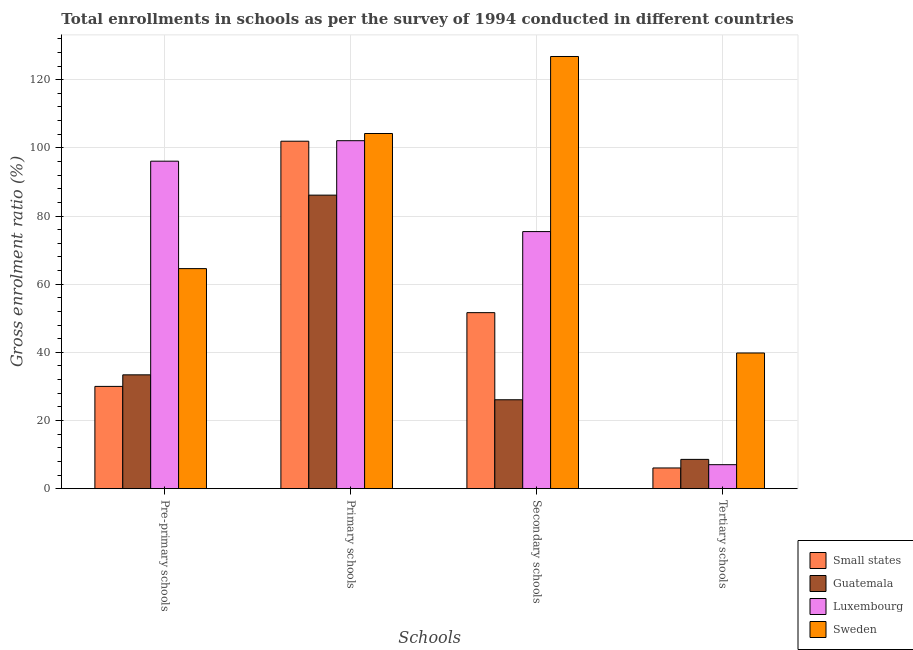How many groups of bars are there?
Provide a succinct answer. 4. Are the number of bars per tick equal to the number of legend labels?
Your answer should be compact. Yes. Are the number of bars on each tick of the X-axis equal?
Offer a very short reply. Yes. What is the label of the 3rd group of bars from the left?
Keep it short and to the point. Secondary schools. What is the gross enrolment ratio in secondary schools in Small states?
Provide a short and direct response. 51.65. Across all countries, what is the maximum gross enrolment ratio in secondary schools?
Your response must be concise. 126.8. Across all countries, what is the minimum gross enrolment ratio in tertiary schools?
Your response must be concise. 6.08. In which country was the gross enrolment ratio in primary schools minimum?
Your response must be concise. Guatemala. What is the total gross enrolment ratio in tertiary schools in the graph?
Your response must be concise. 61.52. What is the difference between the gross enrolment ratio in tertiary schools in Sweden and that in Guatemala?
Keep it short and to the point. 31.21. What is the difference between the gross enrolment ratio in secondary schools in Luxembourg and the gross enrolment ratio in primary schools in Guatemala?
Ensure brevity in your answer.  -10.7. What is the average gross enrolment ratio in primary schools per country?
Your response must be concise. 98.59. What is the difference between the gross enrolment ratio in tertiary schools and gross enrolment ratio in pre-primary schools in Luxembourg?
Ensure brevity in your answer.  -89.05. What is the ratio of the gross enrolment ratio in tertiary schools in Luxembourg to that in Sweden?
Offer a terse response. 0.18. Is the gross enrolment ratio in pre-primary schools in Guatemala less than that in Luxembourg?
Your answer should be very brief. Yes. Is the difference between the gross enrolment ratio in secondary schools in Guatemala and Small states greater than the difference between the gross enrolment ratio in primary schools in Guatemala and Small states?
Offer a very short reply. No. What is the difference between the highest and the second highest gross enrolment ratio in secondary schools?
Your response must be concise. 51.37. What is the difference between the highest and the lowest gross enrolment ratio in primary schools?
Offer a very short reply. 18.08. Is it the case that in every country, the sum of the gross enrolment ratio in tertiary schools and gross enrolment ratio in primary schools is greater than the sum of gross enrolment ratio in secondary schools and gross enrolment ratio in pre-primary schools?
Make the answer very short. No. What does the 3rd bar from the left in Pre-primary schools represents?
Your answer should be compact. Luxembourg. What does the 2nd bar from the right in Secondary schools represents?
Offer a very short reply. Luxembourg. Is it the case that in every country, the sum of the gross enrolment ratio in pre-primary schools and gross enrolment ratio in primary schools is greater than the gross enrolment ratio in secondary schools?
Your answer should be compact. Yes. How many bars are there?
Offer a terse response. 16. Are all the bars in the graph horizontal?
Make the answer very short. No. How many countries are there in the graph?
Make the answer very short. 4. Does the graph contain grids?
Offer a very short reply. Yes. Where does the legend appear in the graph?
Your response must be concise. Bottom right. How are the legend labels stacked?
Make the answer very short. Vertical. What is the title of the graph?
Offer a terse response. Total enrollments in schools as per the survey of 1994 conducted in different countries. What is the label or title of the X-axis?
Ensure brevity in your answer.  Schools. What is the Gross enrolment ratio (%) of Small states in Pre-primary schools?
Provide a short and direct response. 30.01. What is the Gross enrolment ratio (%) of Guatemala in Pre-primary schools?
Offer a very short reply. 33.4. What is the Gross enrolment ratio (%) of Luxembourg in Pre-primary schools?
Your answer should be compact. 96.09. What is the Gross enrolment ratio (%) of Sweden in Pre-primary schools?
Keep it short and to the point. 64.56. What is the Gross enrolment ratio (%) of Small states in Primary schools?
Your answer should be very brief. 101.95. What is the Gross enrolment ratio (%) in Guatemala in Primary schools?
Offer a very short reply. 86.13. What is the Gross enrolment ratio (%) in Luxembourg in Primary schools?
Ensure brevity in your answer.  102.1. What is the Gross enrolment ratio (%) of Sweden in Primary schools?
Your response must be concise. 104.2. What is the Gross enrolment ratio (%) in Small states in Secondary schools?
Make the answer very short. 51.65. What is the Gross enrolment ratio (%) in Guatemala in Secondary schools?
Keep it short and to the point. 26.09. What is the Gross enrolment ratio (%) in Luxembourg in Secondary schools?
Your answer should be very brief. 75.43. What is the Gross enrolment ratio (%) of Sweden in Secondary schools?
Make the answer very short. 126.8. What is the Gross enrolment ratio (%) of Small states in Tertiary schools?
Keep it short and to the point. 6.08. What is the Gross enrolment ratio (%) of Guatemala in Tertiary schools?
Ensure brevity in your answer.  8.59. What is the Gross enrolment ratio (%) in Luxembourg in Tertiary schools?
Your response must be concise. 7.04. What is the Gross enrolment ratio (%) of Sweden in Tertiary schools?
Offer a terse response. 39.81. Across all Schools, what is the maximum Gross enrolment ratio (%) in Small states?
Make the answer very short. 101.95. Across all Schools, what is the maximum Gross enrolment ratio (%) in Guatemala?
Provide a succinct answer. 86.13. Across all Schools, what is the maximum Gross enrolment ratio (%) of Luxembourg?
Provide a succinct answer. 102.1. Across all Schools, what is the maximum Gross enrolment ratio (%) in Sweden?
Offer a very short reply. 126.8. Across all Schools, what is the minimum Gross enrolment ratio (%) in Small states?
Keep it short and to the point. 6.08. Across all Schools, what is the minimum Gross enrolment ratio (%) of Guatemala?
Ensure brevity in your answer.  8.59. Across all Schools, what is the minimum Gross enrolment ratio (%) in Luxembourg?
Your answer should be very brief. 7.04. Across all Schools, what is the minimum Gross enrolment ratio (%) in Sweden?
Your answer should be very brief. 39.81. What is the total Gross enrolment ratio (%) of Small states in the graph?
Make the answer very short. 189.67. What is the total Gross enrolment ratio (%) of Guatemala in the graph?
Keep it short and to the point. 154.21. What is the total Gross enrolment ratio (%) of Luxembourg in the graph?
Your response must be concise. 280.65. What is the total Gross enrolment ratio (%) in Sweden in the graph?
Your response must be concise. 335.38. What is the difference between the Gross enrolment ratio (%) of Small states in Pre-primary schools and that in Primary schools?
Offer a terse response. -71.94. What is the difference between the Gross enrolment ratio (%) in Guatemala in Pre-primary schools and that in Primary schools?
Provide a short and direct response. -52.72. What is the difference between the Gross enrolment ratio (%) in Luxembourg in Pre-primary schools and that in Primary schools?
Give a very brief answer. -6.01. What is the difference between the Gross enrolment ratio (%) of Sweden in Pre-primary schools and that in Primary schools?
Provide a short and direct response. -39.64. What is the difference between the Gross enrolment ratio (%) of Small states in Pre-primary schools and that in Secondary schools?
Your answer should be very brief. -21.64. What is the difference between the Gross enrolment ratio (%) in Guatemala in Pre-primary schools and that in Secondary schools?
Keep it short and to the point. 7.31. What is the difference between the Gross enrolment ratio (%) in Luxembourg in Pre-primary schools and that in Secondary schools?
Your answer should be very brief. 20.66. What is the difference between the Gross enrolment ratio (%) in Sweden in Pre-primary schools and that in Secondary schools?
Your answer should be very brief. -62.24. What is the difference between the Gross enrolment ratio (%) of Small states in Pre-primary schools and that in Tertiary schools?
Ensure brevity in your answer.  23.93. What is the difference between the Gross enrolment ratio (%) of Guatemala in Pre-primary schools and that in Tertiary schools?
Offer a terse response. 24.81. What is the difference between the Gross enrolment ratio (%) in Luxembourg in Pre-primary schools and that in Tertiary schools?
Ensure brevity in your answer.  89.05. What is the difference between the Gross enrolment ratio (%) in Sweden in Pre-primary schools and that in Tertiary schools?
Give a very brief answer. 24.75. What is the difference between the Gross enrolment ratio (%) in Small states in Primary schools and that in Secondary schools?
Provide a short and direct response. 50.3. What is the difference between the Gross enrolment ratio (%) of Guatemala in Primary schools and that in Secondary schools?
Your response must be concise. 60.04. What is the difference between the Gross enrolment ratio (%) of Luxembourg in Primary schools and that in Secondary schools?
Provide a succinct answer. 26.67. What is the difference between the Gross enrolment ratio (%) of Sweden in Primary schools and that in Secondary schools?
Your answer should be very brief. -22.6. What is the difference between the Gross enrolment ratio (%) of Small states in Primary schools and that in Tertiary schools?
Provide a short and direct response. 95.87. What is the difference between the Gross enrolment ratio (%) of Guatemala in Primary schools and that in Tertiary schools?
Keep it short and to the point. 77.53. What is the difference between the Gross enrolment ratio (%) in Luxembourg in Primary schools and that in Tertiary schools?
Ensure brevity in your answer.  95.06. What is the difference between the Gross enrolment ratio (%) of Sweden in Primary schools and that in Tertiary schools?
Provide a succinct answer. 64.4. What is the difference between the Gross enrolment ratio (%) in Small states in Secondary schools and that in Tertiary schools?
Your answer should be very brief. 45.57. What is the difference between the Gross enrolment ratio (%) in Guatemala in Secondary schools and that in Tertiary schools?
Provide a succinct answer. 17.49. What is the difference between the Gross enrolment ratio (%) of Luxembourg in Secondary schools and that in Tertiary schools?
Offer a terse response. 68.39. What is the difference between the Gross enrolment ratio (%) of Sweden in Secondary schools and that in Tertiary schools?
Give a very brief answer. 87. What is the difference between the Gross enrolment ratio (%) of Small states in Pre-primary schools and the Gross enrolment ratio (%) of Guatemala in Primary schools?
Give a very brief answer. -56.12. What is the difference between the Gross enrolment ratio (%) of Small states in Pre-primary schools and the Gross enrolment ratio (%) of Luxembourg in Primary schools?
Your answer should be very brief. -72.09. What is the difference between the Gross enrolment ratio (%) in Small states in Pre-primary schools and the Gross enrolment ratio (%) in Sweden in Primary schools?
Offer a terse response. -74.2. What is the difference between the Gross enrolment ratio (%) of Guatemala in Pre-primary schools and the Gross enrolment ratio (%) of Luxembourg in Primary schools?
Your answer should be compact. -68.69. What is the difference between the Gross enrolment ratio (%) in Guatemala in Pre-primary schools and the Gross enrolment ratio (%) in Sweden in Primary schools?
Keep it short and to the point. -70.8. What is the difference between the Gross enrolment ratio (%) in Luxembourg in Pre-primary schools and the Gross enrolment ratio (%) in Sweden in Primary schools?
Provide a short and direct response. -8.12. What is the difference between the Gross enrolment ratio (%) in Small states in Pre-primary schools and the Gross enrolment ratio (%) in Guatemala in Secondary schools?
Provide a succinct answer. 3.92. What is the difference between the Gross enrolment ratio (%) of Small states in Pre-primary schools and the Gross enrolment ratio (%) of Luxembourg in Secondary schools?
Ensure brevity in your answer.  -45.42. What is the difference between the Gross enrolment ratio (%) of Small states in Pre-primary schools and the Gross enrolment ratio (%) of Sweden in Secondary schools?
Make the answer very short. -96.8. What is the difference between the Gross enrolment ratio (%) in Guatemala in Pre-primary schools and the Gross enrolment ratio (%) in Luxembourg in Secondary schools?
Offer a terse response. -42.03. What is the difference between the Gross enrolment ratio (%) in Guatemala in Pre-primary schools and the Gross enrolment ratio (%) in Sweden in Secondary schools?
Your answer should be very brief. -93.4. What is the difference between the Gross enrolment ratio (%) of Luxembourg in Pre-primary schools and the Gross enrolment ratio (%) of Sweden in Secondary schools?
Your answer should be very brief. -30.71. What is the difference between the Gross enrolment ratio (%) in Small states in Pre-primary schools and the Gross enrolment ratio (%) in Guatemala in Tertiary schools?
Your answer should be compact. 21.41. What is the difference between the Gross enrolment ratio (%) of Small states in Pre-primary schools and the Gross enrolment ratio (%) of Luxembourg in Tertiary schools?
Keep it short and to the point. 22.97. What is the difference between the Gross enrolment ratio (%) in Small states in Pre-primary schools and the Gross enrolment ratio (%) in Sweden in Tertiary schools?
Keep it short and to the point. -9.8. What is the difference between the Gross enrolment ratio (%) of Guatemala in Pre-primary schools and the Gross enrolment ratio (%) of Luxembourg in Tertiary schools?
Keep it short and to the point. 26.36. What is the difference between the Gross enrolment ratio (%) in Guatemala in Pre-primary schools and the Gross enrolment ratio (%) in Sweden in Tertiary schools?
Provide a succinct answer. -6.41. What is the difference between the Gross enrolment ratio (%) of Luxembourg in Pre-primary schools and the Gross enrolment ratio (%) of Sweden in Tertiary schools?
Your response must be concise. 56.28. What is the difference between the Gross enrolment ratio (%) in Small states in Primary schools and the Gross enrolment ratio (%) in Guatemala in Secondary schools?
Your answer should be very brief. 75.86. What is the difference between the Gross enrolment ratio (%) in Small states in Primary schools and the Gross enrolment ratio (%) in Luxembourg in Secondary schools?
Your answer should be compact. 26.52. What is the difference between the Gross enrolment ratio (%) of Small states in Primary schools and the Gross enrolment ratio (%) of Sweden in Secondary schools?
Provide a succinct answer. -24.86. What is the difference between the Gross enrolment ratio (%) in Guatemala in Primary schools and the Gross enrolment ratio (%) in Luxembourg in Secondary schools?
Your response must be concise. 10.7. What is the difference between the Gross enrolment ratio (%) of Guatemala in Primary schools and the Gross enrolment ratio (%) of Sweden in Secondary schools?
Offer a terse response. -40.68. What is the difference between the Gross enrolment ratio (%) of Luxembourg in Primary schools and the Gross enrolment ratio (%) of Sweden in Secondary schools?
Keep it short and to the point. -24.71. What is the difference between the Gross enrolment ratio (%) in Small states in Primary schools and the Gross enrolment ratio (%) in Guatemala in Tertiary schools?
Keep it short and to the point. 93.35. What is the difference between the Gross enrolment ratio (%) in Small states in Primary schools and the Gross enrolment ratio (%) in Luxembourg in Tertiary schools?
Offer a very short reply. 94.91. What is the difference between the Gross enrolment ratio (%) of Small states in Primary schools and the Gross enrolment ratio (%) of Sweden in Tertiary schools?
Provide a short and direct response. 62.14. What is the difference between the Gross enrolment ratio (%) of Guatemala in Primary schools and the Gross enrolment ratio (%) of Luxembourg in Tertiary schools?
Provide a short and direct response. 79.09. What is the difference between the Gross enrolment ratio (%) of Guatemala in Primary schools and the Gross enrolment ratio (%) of Sweden in Tertiary schools?
Keep it short and to the point. 46.32. What is the difference between the Gross enrolment ratio (%) of Luxembourg in Primary schools and the Gross enrolment ratio (%) of Sweden in Tertiary schools?
Offer a terse response. 62.29. What is the difference between the Gross enrolment ratio (%) in Small states in Secondary schools and the Gross enrolment ratio (%) in Guatemala in Tertiary schools?
Provide a short and direct response. 43.05. What is the difference between the Gross enrolment ratio (%) of Small states in Secondary schools and the Gross enrolment ratio (%) of Luxembourg in Tertiary schools?
Make the answer very short. 44.61. What is the difference between the Gross enrolment ratio (%) in Small states in Secondary schools and the Gross enrolment ratio (%) in Sweden in Tertiary schools?
Ensure brevity in your answer.  11.84. What is the difference between the Gross enrolment ratio (%) in Guatemala in Secondary schools and the Gross enrolment ratio (%) in Luxembourg in Tertiary schools?
Give a very brief answer. 19.05. What is the difference between the Gross enrolment ratio (%) in Guatemala in Secondary schools and the Gross enrolment ratio (%) in Sweden in Tertiary schools?
Your answer should be very brief. -13.72. What is the difference between the Gross enrolment ratio (%) of Luxembourg in Secondary schools and the Gross enrolment ratio (%) of Sweden in Tertiary schools?
Ensure brevity in your answer.  35.62. What is the average Gross enrolment ratio (%) in Small states per Schools?
Your answer should be compact. 47.42. What is the average Gross enrolment ratio (%) in Guatemala per Schools?
Give a very brief answer. 38.55. What is the average Gross enrolment ratio (%) in Luxembourg per Schools?
Ensure brevity in your answer.  70.16. What is the average Gross enrolment ratio (%) in Sweden per Schools?
Give a very brief answer. 83.84. What is the difference between the Gross enrolment ratio (%) of Small states and Gross enrolment ratio (%) of Guatemala in Pre-primary schools?
Make the answer very short. -3.4. What is the difference between the Gross enrolment ratio (%) in Small states and Gross enrolment ratio (%) in Luxembourg in Pre-primary schools?
Offer a very short reply. -66.08. What is the difference between the Gross enrolment ratio (%) of Small states and Gross enrolment ratio (%) of Sweden in Pre-primary schools?
Your answer should be very brief. -34.56. What is the difference between the Gross enrolment ratio (%) in Guatemala and Gross enrolment ratio (%) in Luxembourg in Pre-primary schools?
Your answer should be very brief. -62.69. What is the difference between the Gross enrolment ratio (%) in Guatemala and Gross enrolment ratio (%) in Sweden in Pre-primary schools?
Your answer should be very brief. -31.16. What is the difference between the Gross enrolment ratio (%) in Luxembourg and Gross enrolment ratio (%) in Sweden in Pre-primary schools?
Keep it short and to the point. 31.53. What is the difference between the Gross enrolment ratio (%) of Small states and Gross enrolment ratio (%) of Guatemala in Primary schools?
Make the answer very short. 15.82. What is the difference between the Gross enrolment ratio (%) of Small states and Gross enrolment ratio (%) of Sweden in Primary schools?
Keep it short and to the point. -2.26. What is the difference between the Gross enrolment ratio (%) of Guatemala and Gross enrolment ratio (%) of Luxembourg in Primary schools?
Provide a succinct answer. -15.97. What is the difference between the Gross enrolment ratio (%) of Guatemala and Gross enrolment ratio (%) of Sweden in Primary schools?
Give a very brief answer. -18.08. What is the difference between the Gross enrolment ratio (%) of Luxembourg and Gross enrolment ratio (%) of Sweden in Primary schools?
Provide a succinct answer. -2.11. What is the difference between the Gross enrolment ratio (%) of Small states and Gross enrolment ratio (%) of Guatemala in Secondary schools?
Give a very brief answer. 25.56. What is the difference between the Gross enrolment ratio (%) of Small states and Gross enrolment ratio (%) of Luxembourg in Secondary schools?
Provide a succinct answer. -23.78. What is the difference between the Gross enrolment ratio (%) in Small states and Gross enrolment ratio (%) in Sweden in Secondary schools?
Provide a succinct answer. -75.16. What is the difference between the Gross enrolment ratio (%) in Guatemala and Gross enrolment ratio (%) in Luxembourg in Secondary schools?
Give a very brief answer. -49.34. What is the difference between the Gross enrolment ratio (%) in Guatemala and Gross enrolment ratio (%) in Sweden in Secondary schools?
Give a very brief answer. -100.71. What is the difference between the Gross enrolment ratio (%) in Luxembourg and Gross enrolment ratio (%) in Sweden in Secondary schools?
Ensure brevity in your answer.  -51.37. What is the difference between the Gross enrolment ratio (%) in Small states and Gross enrolment ratio (%) in Guatemala in Tertiary schools?
Provide a short and direct response. -2.52. What is the difference between the Gross enrolment ratio (%) in Small states and Gross enrolment ratio (%) in Luxembourg in Tertiary schools?
Your answer should be compact. -0.96. What is the difference between the Gross enrolment ratio (%) in Small states and Gross enrolment ratio (%) in Sweden in Tertiary schools?
Your answer should be very brief. -33.73. What is the difference between the Gross enrolment ratio (%) in Guatemala and Gross enrolment ratio (%) in Luxembourg in Tertiary schools?
Give a very brief answer. 1.56. What is the difference between the Gross enrolment ratio (%) of Guatemala and Gross enrolment ratio (%) of Sweden in Tertiary schools?
Offer a very short reply. -31.21. What is the difference between the Gross enrolment ratio (%) in Luxembourg and Gross enrolment ratio (%) in Sweden in Tertiary schools?
Your response must be concise. -32.77. What is the ratio of the Gross enrolment ratio (%) in Small states in Pre-primary schools to that in Primary schools?
Offer a terse response. 0.29. What is the ratio of the Gross enrolment ratio (%) of Guatemala in Pre-primary schools to that in Primary schools?
Keep it short and to the point. 0.39. What is the ratio of the Gross enrolment ratio (%) of Sweden in Pre-primary schools to that in Primary schools?
Provide a short and direct response. 0.62. What is the ratio of the Gross enrolment ratio (%) of Small states in Pre-primary schools to that in Secondary schools?
Keep it short and to the point. 0.58. What is the ratio of the Gross enrolment ratio (%) in Guatemala in Pre-primary schools to that in Secondary schools?
Your answer should be very brief. 1.28. What is the ratio of the Gross enrolment ratio (%) in Luxembourg in Pre-primary schools to that in Secondary schools?
Provide a short and direct response. 1.27. What is the ratio of the Gross enrolment ratio (%) of Sweden in Pre-primary schools to that in Secondary schools?
Provide a short and direct response. 0.51. What is the ratio of the Gross enrolment ratio (%) of Small states in Pre-primary schools to that in Tertiary schools?
Give a very brief answer. 4.94. What is the ratio of the Gross enrolment ratio (%) in Guatemala in Pre-primary schools to that in Tertiary schools?
Make the answer very short. 3.89. What is the ratio of the Gross enrolment ratio (%) in Luxembourg in Pre-primary schools to that in Tertiary schools?
Ensure brevity in your answer.  13.65. What is the ratio of the Gross enrolment ratio (%) of Sweden in Pre-primary schools to that in Tertiary schools?
Your response must be concise. 1.62. What is the ratio of the Gross enrolment ratio (%) of Small states in Primary schools to that in Secondary schools?
Your answer should be compact. 1.97. What is the ratio of the Gross enrolment ratio (%) in Guatemala in Primary schools to that in Secondary schools?
Give a very brief answer. 3.3. What is the ratio of the Gross enrolment ratio (%) in Luxembourg in Primary schools to that in Secondary schools?
Keep it short and to the point. 1.35. What is the ratio of the Gross enrolment ratio (%) in Sweden in Primary schools to that in Secondary schools?
Ensure brevity in your answer.  0.82. What is the ratio of the Gross enrolment ratio (%) in Small states in Primary schools to that in Tertiary schools?
Your response must be concise. 16.78. What is the ratio of the Gross enrolment ratio (%) in Guatemala in Primary schools to that in Tertiary schools?
Offer a very short reply. 10.02. What is the ratio of the Gross enrolment ratio (%) of Luxembourg in Primary schools to that in Tertiary schools?
Ensure brevity in your answer.  14.51. What is the ratio of the Gross enrolment ratio (%) in Sweden in Primary schools to that in Tertiary schools?
Ensure brevity in your answer.  2.62. What is the ratio of the Gross enrolment ratio (%) of Small states in Secondary schools to that in Tertiary schools?
Your answer should be compact. 8.5. What is the ratio of the Gross enrolment ratio (%) of Guatemala in Secondary schools to that in Tertiary schools?
Offer a terse response. 3.04. What is the ratio of the Gross enrolment ratio (%) in Luxembourg in Secondary schools to that in Tertiary schools?
Your response must be concise. 10.72. What is the ratio of the Gross enrolment ratio (%) of Sweden in Secondary schools to that in Tertiary schools?
Offer a very short reply. 3.19. What is the difference between the highest and the second highest Gross enrolment ratio (%) of Small states?
Your answer should be compact. 50.3. What is the difference between the highest and the second highest Gross enrolment ratio (%) of Guatemala?
Keep it short and to the point. 52.72. What is the difference between the highest and the second highest Gross enrolment ratio (%) of Luxembourg?
Ensure brevity in your answer.  6.01. What is the difference between the highest and the second highest Gross enrolment ratio (%) of Sweden?
Provide a short and direct response. 22.6. What is the difference between the highest and the lowest Gross enrolment ratio (%) of Small states?
Your answer should be very brief. 95.87. What is the difference between the highest and the lowest Gross enrolment ratio (%) of Guatemala?
Offer a very short reply. 77.53. What is the difference between the highest and the lowest Gross enrolment ratio (%) in Luxembourg?
Offer a terse response. 95.06. What is the difference between the highest and the lowest Gross enrolment ratio (%) of Sweden?
Offer a very short reply. 87. 